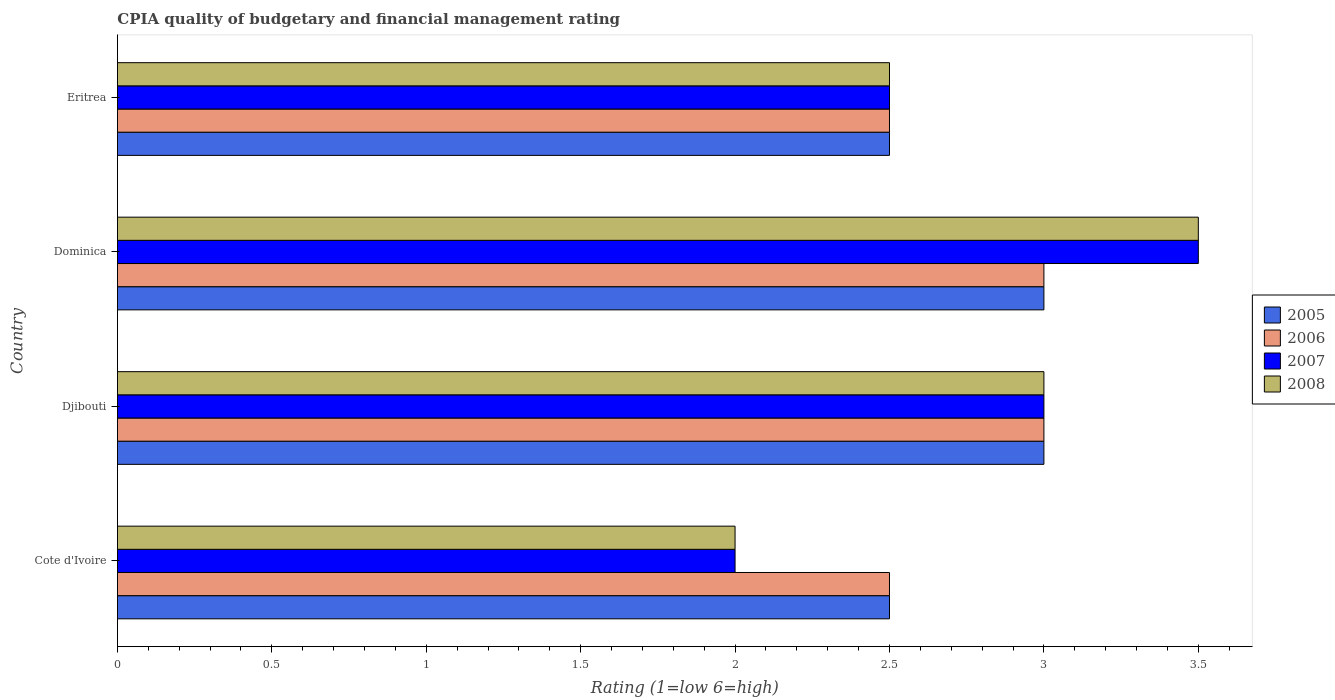How many different coloured bars are there?
Offer a very short reply. 4. How many groups of bars are there?
Your answer should be very brief. 4. Are the number of bars on each tick of the Y-axis equal?
Give a very brief answer. Yes. How many bars are there on the 1st tick from the top?
Make the answer very short. 4. What is the label of the 3rd group of bars from the top?
Make the answer very short. Djibouti. In how many cases, is the number of bars for a given country not equal to the number of legend labels?
Give a very brief answer. 0. Across all countries, what is the maximum CPIA rating in 2008?
Provide a succinct answer. 3.5. In which country was the CPIA rating in 2007 maximum?
Give a very brief answer. Dominica. In which country was the CPIA rating in 2005 minimum?
Offer a very short reply. Cote d'Ivoire. What is the average CPIA rating in 2008 per country?
Provide a short and direct response. 2.75. What is the difference between the CPIA rating in 2006 and CPIA rating in 2005 in Dominica?
Make the answer very short. 0. What is the ratio of the CPIA rating in 2007 in Cote d'Ivoire to that in Djibouti?
Give a very brief answer. 0.67. Is the CPIA rating in 2005 in Dominica less than that in Eritrea?
Your response must be concise. No. Is the difference between the CPIA rating in 2006 in Cote d'Ivoire and Eritrea greater than the difference between the CPIA rating in 2005 in Cote d'Ivoire and Eritrea?
Give a very brief answer. No. What is the difference between the highest and the second highest CPIA rating in 2005?
Give a very brief answer. 0. Is the sum of the CPIA rating in 2006 in Dominica and Eritrea greater than the maximum CPIA rating in 2007 across all countries?
Make the answer very short. Yes. Is it the case that in every country, the sum of the CPIA rating in 2006 and CPIA rating in 2007 is greater than the sum of CPIA rating in 2008 and CPIA rating in 2005?
Provide a short and direct response. No. Is it the case that in every country, the sum of the CPIA rating in 2007 and CPIA rating in 2005 is greater than the CPIA rating in 2008?
Provide a succinct answer. Yes. What is the difference between two consecutive major ticks on the X-axis?
Your answer should be compact. 0.5. Are the values on the major ticks of X-axis written in scientific E-notation?
Your answer should be very brief. No. Does the graph contain grids?
Give a very brief answer. No. Where does the legend appear in the graph?
Provide a succinct answer. Center right. What is the title of the graph?
Your answer should be compact. CPIA quality of budgetary and financial management rating. Does "2001" appear as one of the legend labels in the graph?
Your response must be concise. No. What is the label or title of the Y-axis?
Keep it short and to the point. Country. What is the Rating (1=low 6=high) of 2005 in Cote d'Ivoire?
Keep it short and to the point. 2.5. What is the Rating (1=low 6=high) in 2006 in Cote d'Ivoire?
Give a very brief answer. 2.5. What is the Rating (1=low 6=high) in 2005 in Djibouti?
Your answer should be compact. 3. What is the Rating (1=low 6=high) of 2006 in Dominica?
Make the answer very short. 3. What is the Rating (1=low 6=high) in 2007 in Dominica?
Offer a terse response. 3.5. What is the Rating (1=low 6=high) in 2008 in Dominica?
Give a very brief answer. 3.5. What is the Rating (1=low 6=high) in 2005 in Eritrea?
Make the answer very short. 2.5. What is the Rating (1=low 6=high) in 2006 in Eritrea?
Offer a very short reply. 2.5. What is the Rating (1=low 6=high) of 2007 in Eritrea?
Keep it short and to the point. 2.5. Across all countries, what is the maximum Rating (1=low 6=high) in 2005?
Provide a short and direct response. 3. Across all countries, what is the maximum Rating (1=low 6=high) in 2007?
Ensure brevity in your answer.  3.5. Across all countries, what is the maximum Rating (1=low 6=high) in 2008?
Provide a short and direct response. 3.5. Across all countries, what is the minimum Rating (1=low 6=high) of 2006?
Offer a very short reply. 2.5. Across all countries, what is the minimum Rating (1=low 6=high) of 2008?
Provide a succinct answer. 2. What is the total Rating (1=low 6=high) in 2005 in the graph?
Your answer should be compact. 11. What is the total Rating (1=low 6=high) of 2006 in the graph?
Ensure brevity in your answer.  11. What is the total Rating (1=low 6=high) of 2007 in the graph?
Give a very brief answer. 11. What is the difference between the Rating (1=low 6=high) of 2005 in Cote d'Ivoire and that in Djibouti?
Offer a terse response. -0.5. What is the difference between the Rating (1=low 6=high) in 2006 in Cote d'Ivoire and that in Djibouti?
Your response must be concise. -0.5. What is the difference between the Rating (1=low 6=high) in 2008 in Cote d'Ivoire and that in Djibouti?
Your response must be concise. -1. What is the difference between the Rating (1=low 6=high) in 2006 in Cote d'Ivoire and that in Dominica?
Your response must be concise. -0.5. What is the difference between the Rating (1=low 6=high) in 2006 in Cote d'Ivoire and that in Eritrea?
Ensure brevity in your answer.  0. What is the difference between the Rating (1=low 6=high) of 2005 in Djibouti and that in Dominica?
Your response must be concise. 0. What is the difference between the Rating (1=low 6=high) in 2008 in Djibouti and that in Dominica?
Offer a very short reply. -0.5. What is the difference between the Rating (1=low 6=high) in 2007 in Djibouti and that in Eritrea?
Keep it short and to the point. 0.5. What is the difference between the Rating (1=low 6=high) in 2008 in Djibouti and that in Eritrea?
Give a very brief answer. 0.5. What is the difference between the Rating (1=low 6=high) of 2006 in Dominica and that in Eritrea?
Make the answer very short. 0.5. What is the difference between the Rating (1=low 6=high) of 2005 in Cote d'Ivoire and the Rating (1=low 6=high) of 2006 in Djibouti?
Your answer should be very brief. -0.5. What is the difference between the Rating (1=low 6=high) in 2005 in Cote d'Ivoire and the Rating (1=low 6=high) in 2007 in Djibouti?
Your answer should be very brief. -0.5. What is the difference between the Rating (1=low 6=high) in 2006 in Cote d'Ivoire and the Rating (1=low 6=high) in 2007 in Djibouti?
Ensure brevity in your answer.  -0.5. What is the difference between the Rating (1=low 6=high) of 2006 in Cote d'Ivoire and the Rating (1=low 6=high) of 2008 in Djibouti?
Ensure brevity in your answer.  -0.5. What is the difference between the Rating (1=low 6=high) of 2005 in Cote d'Ivoire and the Rating (1=low 6=high) of 2007 in Dominica?
Your answer should be very brief. -1. What is the difference between the Rating (1=low 6=high) in 2005 in Cote d'Ivoire and the Rating (1=low 6=high) in 2008 in Dominica?
Offer a terse response. -1. What is the difference between the Rating (1=low 6=high) in 2006 in Cote d'Ivoire and the Rating (1=low 6=high) in 2007 in Dominica?
Give a very brief answer. -1. What is the difference between the Rating (1=low 6=high) of 2006 in Cote d'Ivoire and the Rating (1=low 6=high) of 2008 in Dominica?
Your answer should be compact. -1. What is the difference between the Rating (1=low 6=high) of 2005 in Cote d'Ivoire and the Rating (1=low 6=high) of 2008 in Eritrea?
Offer a terse response. 0. What is the difference between the Rating (1=low 6=high) of 2006 in Cote d'Ivoire and the Rating (1=low 6=high) of 2007 in Eritrea?
Your answer should be very brief. 0. What is the difference between the Rating (1=low 6=high) in 2005 in Djibouti and the Rating (1=low 6=high) in 2008 in Dominica?
Provide a short and direct response. -0.5. What is the difference between the Rating (1=low 6=high) in 2006 in Djibouti and the Rating (1=low 6=high) in 2007 in Dominica?
Give a very brief answer. -0.5. What is the difference between the Rating (1=low 6=high) of 2005 in Dominica and the Rating (1=low 6=high) of 2007 in Eritrea?
Offer a very short reply. 0.5. What is the difference between the Rating (1=low 6=high) of 2005 in Dominica and the Rating (1=low 6=high) of 2008 in Eritrea?
Ensure brevity in your answer.  0.5. What is the difference between the Rating (1=low 6=high) of 2006 in Dominica and the Rating (1=low 6=high) of 2007 in Eritrea?
Give a very brief answer. 0.5. What is the difference between the Rating (1=low 6=high) of 2007 in Dominica and the Rating (1=low 6=high) of 2008 in Eritrea?
Provide a succinct answer. 1. What is the average Rating (1=low 6=high) in 2005 per country?
Offer a terse response. 2.75. What is the average Rating (1=low 6=high) in 2006 per country?
Offer a very short reply. 2.75. What is the average Rating (1=low 6=high) in 2007 per country?
Your response must be concise. 2.75. What is the average Rating (1=low 6=high) of 2008 per country?
Your answer should be compact. 2.75. What is the difference between the Rating (1=low 6=high) in 2005 and Rating (1=low 6=high) in 2008 in Cote d'Ivoire?
Provide a succinct answer. 0.5. What is the difference between the Rating (1=low 6=high) in 2006 and Rating (1=low 6=high) in 2007 in Cote d'Ivoire?
Make the answer very short. 0.5. What is the difference between the Rating (1=low 6=high) of 2005 and Rating (1=low 6=high) of 2006 in Djibouti?
Provide a short and direct response. 0. What is the difference between the Rating (1=low 6=high) in 2005 and Rating (1=low 6=high) in 2007 in Djibouti?
Ensure brevity in your answer.  0. What is the difference between the Rating (1=low 6=high) in 2005 and Rating (1=low 6=high) in 2008 in Djibouti?
Make the answer very short. 0. What is the difference between the Rating (1=low 6=high) of 2006 and Rating (1=low 6=high) of 2007 in Djibouti?
Your answer should be very brief. 0. What is the difference between the Rating (1=low 6=high) in 2007 and Rating (1=low 6=high) in 2008 in Djibouti?
Make the answer very short. 0. What is the difference between the Rating (1=low 6=high) of 2005 and Rating (1=low 6=high) of 2006 in Dominica?
Your answer should be compact. 0. What is the difference between the Rating (1=low 6=high) of 2005 and Rating (1=low 6=high) of 2007 in Dominica?
Make the answer very short. -0.5. What is the difference between the Rating (1=low 6=high) of 2005 and Rating (1=low 6=high) of 2006 in Eritrea?
Offer a terse response. 0. What is the difference between the Rating (1=low 6=high) of 2005 and Rating (1=low 6=high) of 2007 in Eritrea?
Ensure brevity in your answer.  0. What is the difference between the Rating (1=low 6=high) of 2005 and Rating (1=low 6=high) of 2008 in Eritrea?
Ensure brevity in your answer.  0. What is the difference between the Rating (1=low 6=high) in 2006 and Rating (1=low 6=high) in 2007 in Eritrea?
Your answer should be compact. 0. What is the ratio of the Rating (1=low 6=high) in 2005 in Cote d'Ivoire to that in Dominica?
Make the answer very short. 0.83. What is the ratio of the Rating (1=low 6=high) of 2007 in Cote d'Ivoire to that in Dominica?
Ensure brevity in your answer.  0.57. What is the ratio of the Rating (1=low 6=high) of 2008 in Cote d'Ivoire to that in Dominica?
Make the answer very short. 0.57. What is the ratio of the Rating (1=low 6=high) in 2006 in Djibouti to that in Dominica?
Offer a terse response. 1. What is the ratio of the Rating (1=low 6=high) in 2007 in Djibouti to that in Dominica?
Give a very brief answer. 0.86. What is the ratio of the Rating (1=low 6=high) in 2005 in Djibouti to that in Eritrea?
Make the answer very short. 1.2. What is the ratio of the Rating (1=low 6=high) of 2006 in Djibouti to that in Eritrea?
Ensure brevity in your answer.  1.2. What is the ratio of the Rating (1=low 6=high) in 2007 in Djibouti to that in Eritrea?
Ensure brevity in your answer.  1.2. What is the ratio of the Rating (1=low 6=high) in 2008 in Djibouti to that in Eritrea?
Ensure brevity in your answer.  1.2. What is the ratio of the Rating (1=low 6=high) in 2006 in Dominica to that in Eritrea?
Offer a very short reply. 1.2. What is the difference between the highest and the second highest Rating (1=low 6=high) in 2005?
Provide a short and direct response. 0. What is the difference between the highest and the second highest Rating (1=low 6=high) in 2008?
Offer a very short reply. 0.5. What is the difference between the highest and the lowest Rating (1=low 6=high) of 2006?
Make the answer very short. 0.5. What is the difference between the highest and the lowest Rating (1=low 6=high) in 2008?
Provide a short and direct response. 1.5. 